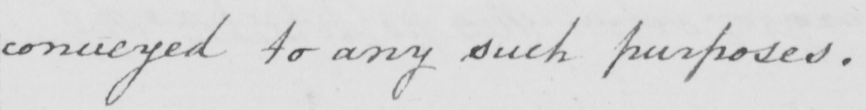What does this handwritten line say? conveyed to any such purposes . 